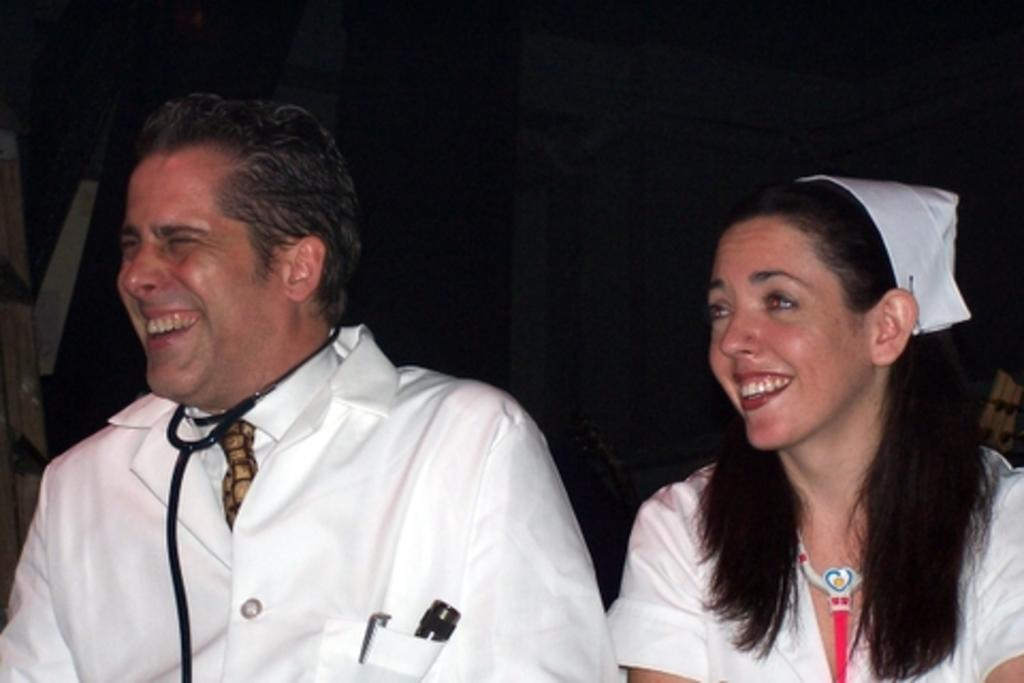How many people are in the image? There are two persons in the image. What are the persons wearing? The persons are wearing white coats. What medical tool can be seen around their necks? The persons have stethoscopes around their necks. What emotion are the persons expressing in the image? The persons are laughing. What is the color of the background in the image? The background of the image is dark. What type of rake is being used by one of the persons in the image? There is no rake present in the image; the persons are wearing white coats and have stethoscopes around their necks. Can you tell me how many rings are visible on the fingers of the persons in the image? There is no mention of rings in the image; the persons are wearing white coats and have stethoscopes around their necks. 